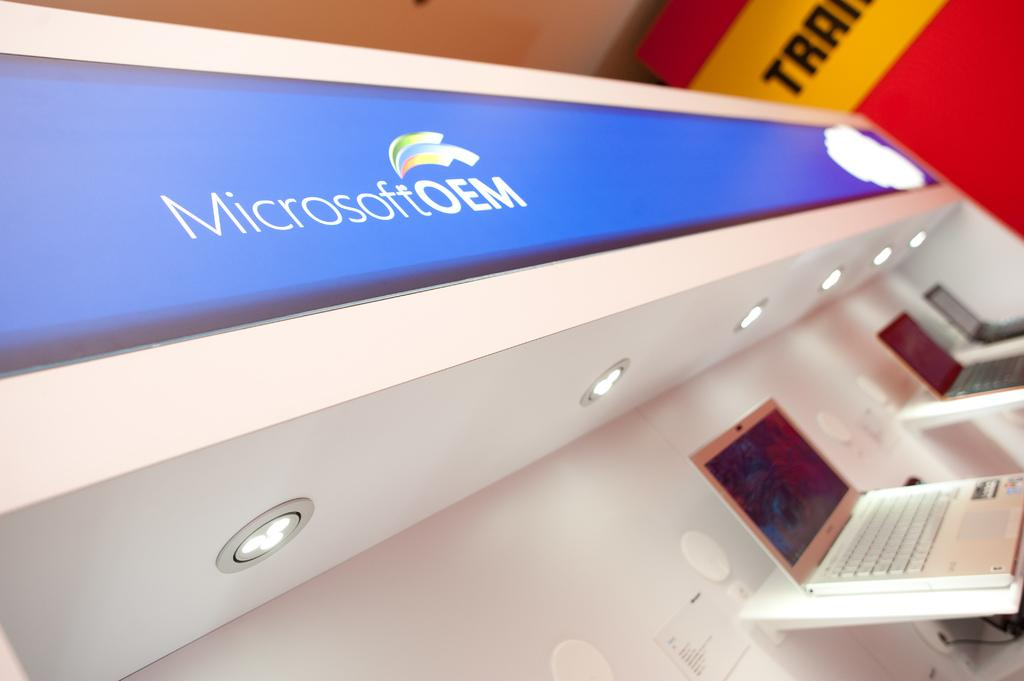<image>
Summarize the visual content of the image. A sign at a store says Microsoft OEM. 